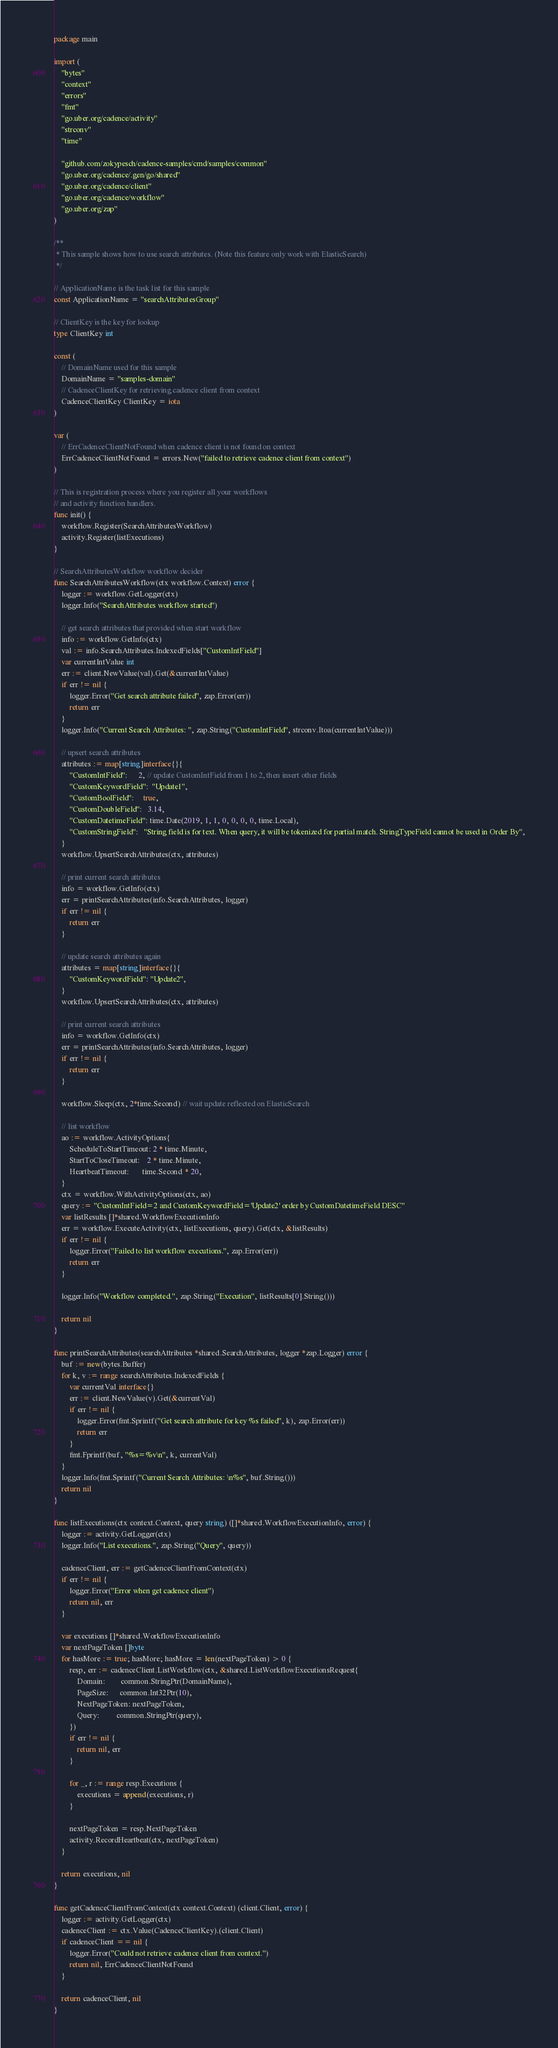<code> <loc_0><loc_0><loc_500><loc_500><_Go_>package main

import (
	"bytes"
	"context"
	"errors"
	"fmt"
	"go.uber.org/cadence/activity"
	"strconv"
	"time"

	"github.com/zokypesch/cadence-samples/cmd/samples/common"
	"go.uber.org/cadence/.gen/go/shared"
	"go.uber.org/cadence/client"
	"go.uber.org/cadence/workflow"
	"go.uber.org/zap"
)

/**
 * This sample shows how to use search attributes. (Note this feature only work with ElasticSearch)
 */

// ApplicationName is the task list for this sample
const ApplicationName = "searchAttributesGroup"

// ClientKey is the key for lookup
type ClientKey int

const (
	// DomainName used for this sample
	DomainName = "samples-domain"
	// CadenceClientKey for retrieving cadence client from context
	CadenceClientKey ClientKey = iota
)

var (
	// ErrCadenceClientNotFound when cadence client is not found on context
	ErrCadenceClientNotFound = errors.New("failed to retrieve cadence client from context")
)

// This is registration process where you register all your workflows
// and activity function handlers.
func init() {
	workflow.Register(SearchAttributesWorkflow)
	activity.Register(listExecutions)
}

// SearchAttributesWorkflow workflow decider
func SearchAttributesWorkflow(ctx workflow.Context) error {
	logger := workflow.GetLogger(ctx)
	logger.Info("SearchAttributes workflow started")

	// get search attributes that provided when start workflow
	info := workflow.GetInfo(ctx)
	val := info.SearchAttributes.IndexedFields["CustomIntField"]
	var currentIntValue int
	err := client.NewValue(val).Get(&currentIntValue)
	if err != nil {
		logger.Error("Get search attribute failed", zap.Error(err))
		return err
	}
	logger.Info("Current Search Attributes: ", zap.String("CustomIntField", strconv.Itoa(currentIntValue)))

	// upsert search attributes
	attributes := map[string]interface{}{
		"CustomIntField":      2, // update CustomIntField from 1 to 2, then insert other fields
		"CustomKeywordField":  "Update1",
		"CustomBoolField":     true,
		"CustomDoubleField":   3.14,
		"CustomDatetimeField": time.Date(2019, 1, 1, 0, 0, 0, 0, time.Local),
		"CustomStringField":   "String field is for text. When query, it will be tokenized for partial match. StringTypeField cannot be used in Order By",
	}
	workflow.UpsertSearchAttributes(ctx, attributes)

	// print current search attributes
	info = workflow.GetInfo(ctx)
	err = printSearchAttributes(info.SearchAttributes, logger)
	if err != nil {
		return err
	}

	// update search attributes again
	attributes = map[string]interface{}{
		"CustomKeywordField": "Update2",
	}
	workflow.UpsertSearchAttributes(ctx, attributes)

	// print current search attributes
	info = workflow.GetInfo(ctx)
	err = printSearchAttributes(info.SearchAttributes, logger)
	if err != nil {
		return err
	}

	workflow.Sleep(ctx, 2*time.Second) // wait update reflected on ElasticSearch

	// list workflow
	ao := workflow.ActivityOptions{
		ScheduleToStartTimeout: 2 * time.Minute,
		StartToCloseTimeout:    2 * time.Minute,
		HeartbeatTimeout:       time.Second * 20,
	}
	ctx = workflow.WithActivityOptions(ctx, ao)
	query := "CustomIntField=2 and CustomKeywordField='Update2' order by CustomDatetimeField DESC"
	var listResults []*shared.WorkflowExecutionInfo
	err = workflow.ExecuteActivity(ctx, listExecutions, query).Get(ctx, &listResults)
	if err != nil {
		logger.Error("Failed to list workflow executions.", zap.Error(err))
		return err
	}

	logger.Info("Workflow completed.", zap.String("Execution", listResults[0].String()))

	return nil
}

func printSearchAttributes(searchAttributes *shared.SearchAttributes, logger *zap.Logger) error {
	buf := new(bytes.Buffer)
	for k, v := range searchAttributes.IndexedFields {
		var currentVal interface{}
		err := client.NewValue(v).Get(&currentVal)
		if err != nil {
			logger.Error(fmt.Sprintf("Get search attribute for key %s failed", k), zap.Error(err))
			return err
		}
		fmt.Fprintf(buf, "%s=%v\n", k, currentVal)
	}
	logger.Info(fmt.Sprintf("Current Search Attributes: \n%s", buf.String()))
	return nil
}

func listExecutions(ctx context.Context, query string) ([]*shared.WorkflowExecutionInfo, error) {
	logger := activity.GetLogger(ctx)
	logger.Info("List executions.", zap.String("Query", query))

	cadenceClient, err := getCadenceClientFromContext(ctx)
	if err != nil {
		logger.Error("Error when get cadence client")
		return nil, err
	}

	var executions []*shared.WorkflowExecutionInfo
	var nextPageToken []byte
	for hasMore := true; hasMore; hasMore = len(nextPageToken) > 0 {
		resp, err := cadenceClient.ListWorkflow(ctx, &shared.ListWorkflowExecutionsRequest{
			Domain:        common.StringPtr(DomainName),
			PageSize:      common.Int32Ptr(10),
			NextPageToken: nextPageToken,
			Query:         common.StringPtr(query),
		})
		if err != nil {
			return nil, err
		}

		for _, r := range resp.Executions {
			executions = append(executions, r)
		}

		nextPageToken = resp.NextPageToken
		activity.RecordHeartbeat(ctx, nextPageToken)
	}

	return executions, nil
}

func getCadenceClientFromContext(ctx context.Context) (client.Client, error) {
	logger := activity.GetLogger(ctx)
	cadenceClient := ctx.Value(CadenceClientKey).(client.Client)
	if cadenceClient == nil {
		logger.Error("Could not retrieve cadence client from context.")
		return nil, ErrCadenceClientNotFound
	}

	return cadenceClient, nil
}
</code> 